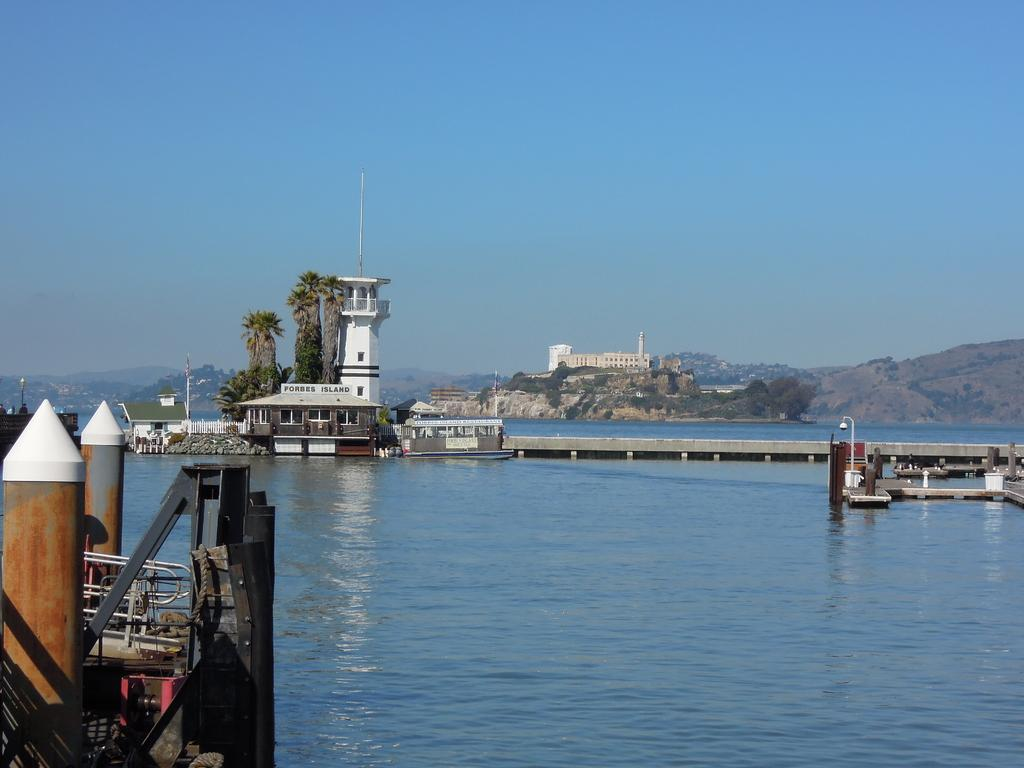What type of water-based structure can be seen in the image? There is a boat harbor in the image. What is on the water in the image? There is a boat on the water in the image. What type of architectural feature is present in the image? There is a bridge in the image. What type of residential structures are visible in the image? There are houses in the image. What type of vegetation is present in the image? There are trees in the image. What type of natural landform is visible in the image? There are hills in the image. What is visible in the background of the image? The sky is visible in the background of the image. Where is the army located in the image? There is no army present in the image. What type of gardening tool can be seen in the image? There is no gardening tool present in the image. What type of container is visible in the image? There is no container present in the image. 